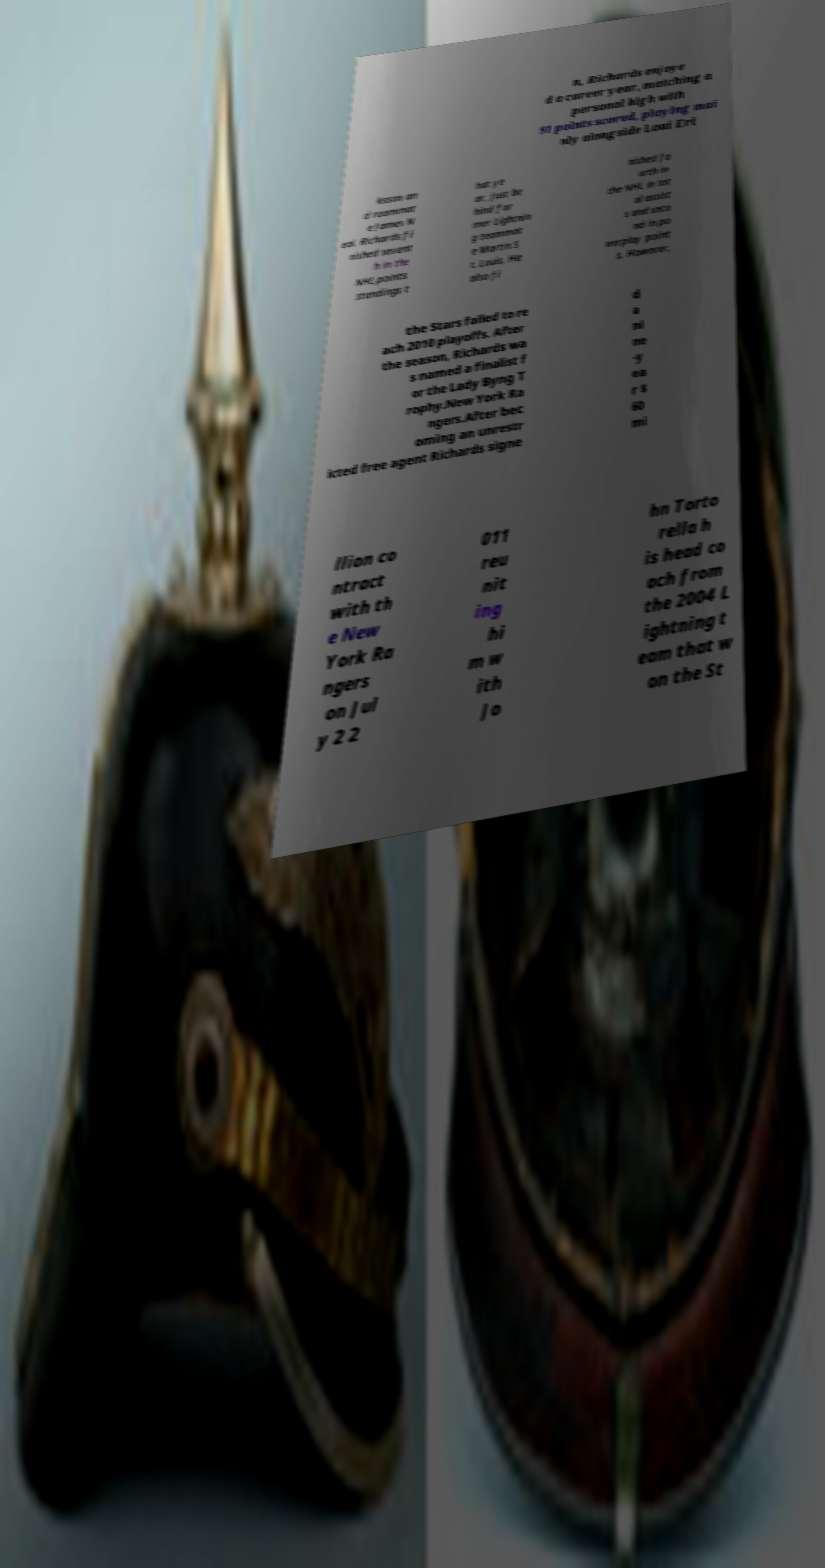Could you extract and type out the text from this image? n, Richards enjoye d a career year, matching a personal high with 91 points scored, playing mai nly alongside Loui Eri ksson an d roommat e James N eal. Richards fi nished sevent h in the NHL points standings t hat ye ar, just be hind for mer Lightnin g teammat e Martin S t. Louis. He also fi nished fo urth in the NHL in tot al assist s and seco nd in po werplay point s. However, the Stars failed to re ach 2010 playoffs. After the season, Richards wa s named a finalist f or the Lady Byng T rophy.New York Ra ngers.After bec oming an unrestr icted free agent Richards signe d a ni ne -y ea r $ 60 mi llion co ntract with th e New York Ra ngers on Jul y 2 2 011 reu nit ing hi m w ith Jo hn Torto rella h is head co ach from the 2004 L ightning t eam that w on the St 